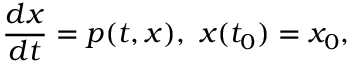Convert formula to latex. <formula><loc_0><loc_0><loc_500><loc_500>{ \frac { d x } { d t } } = p ( t , x ) , x ( t _ { 0 } ) = x _ { 0 } ,</formula> 